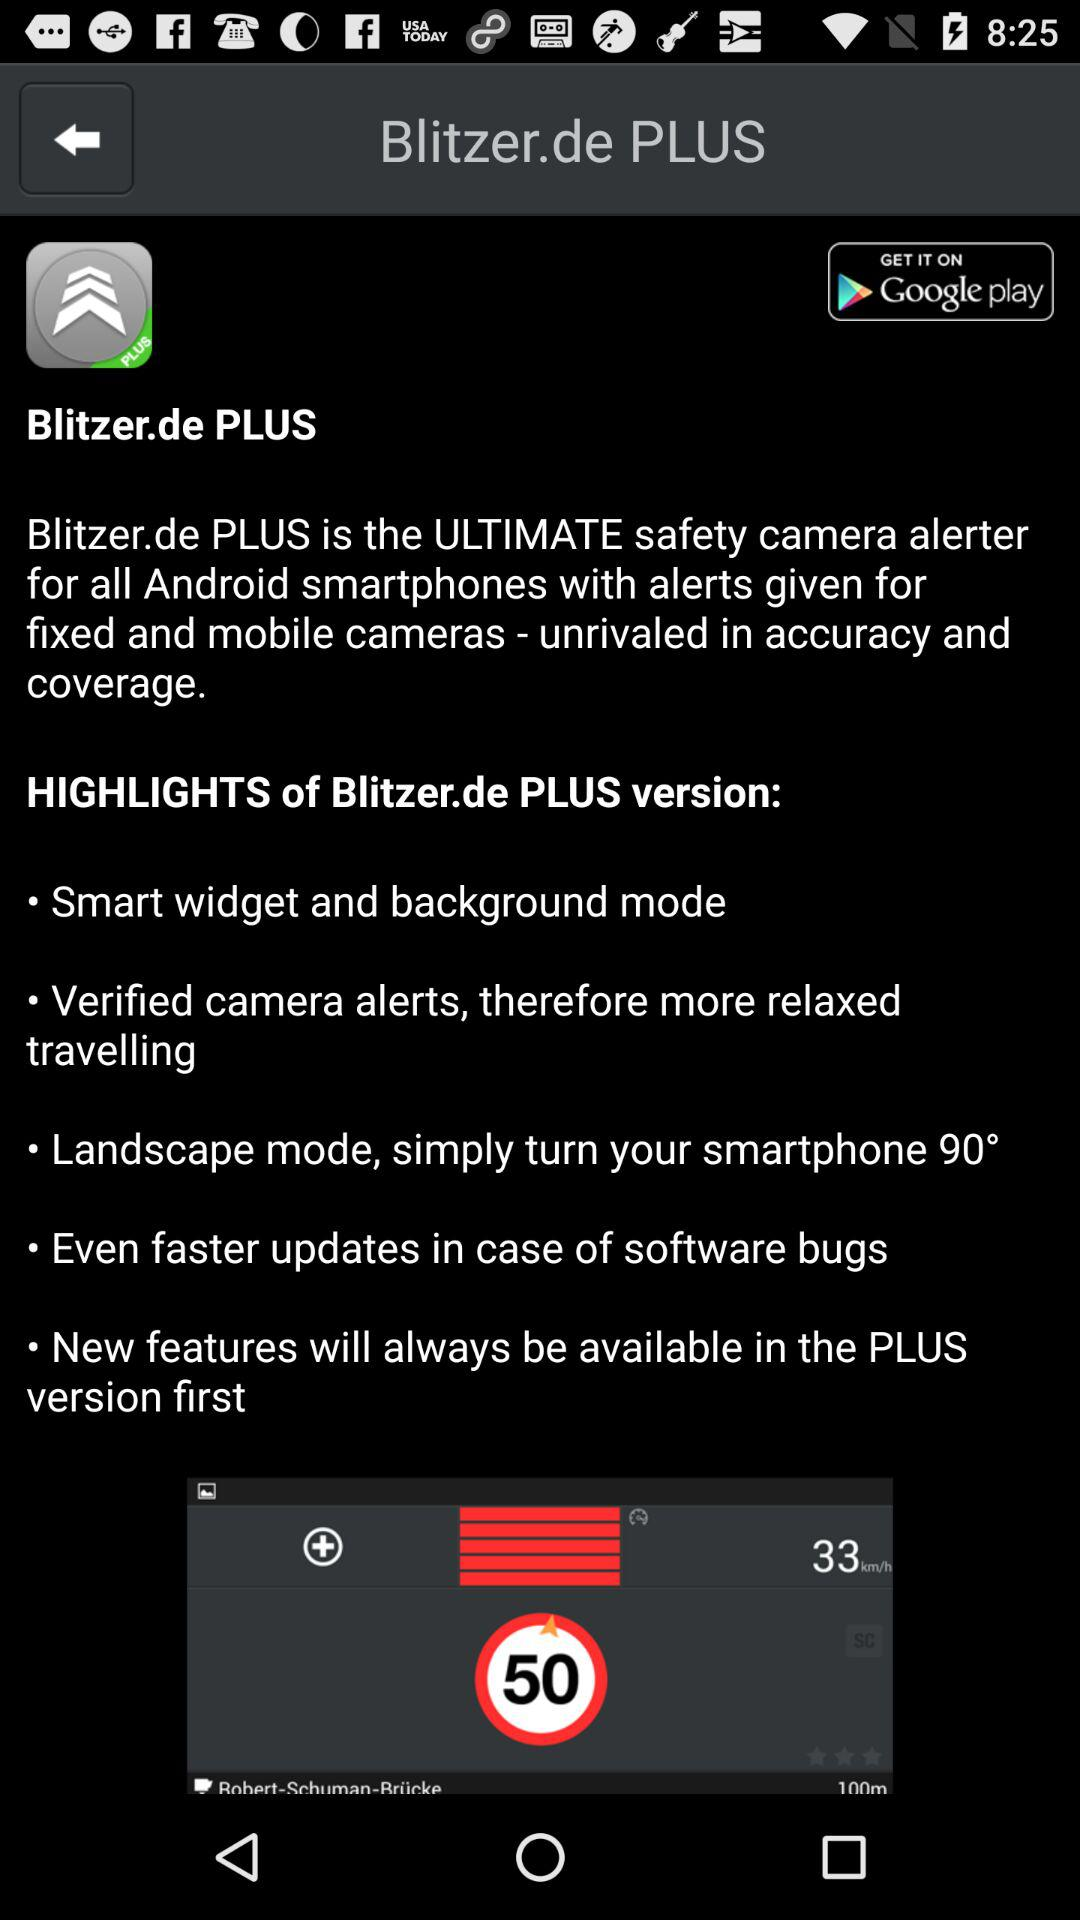What is the name of the application? The application name is "Blitzer.de PLUS". 